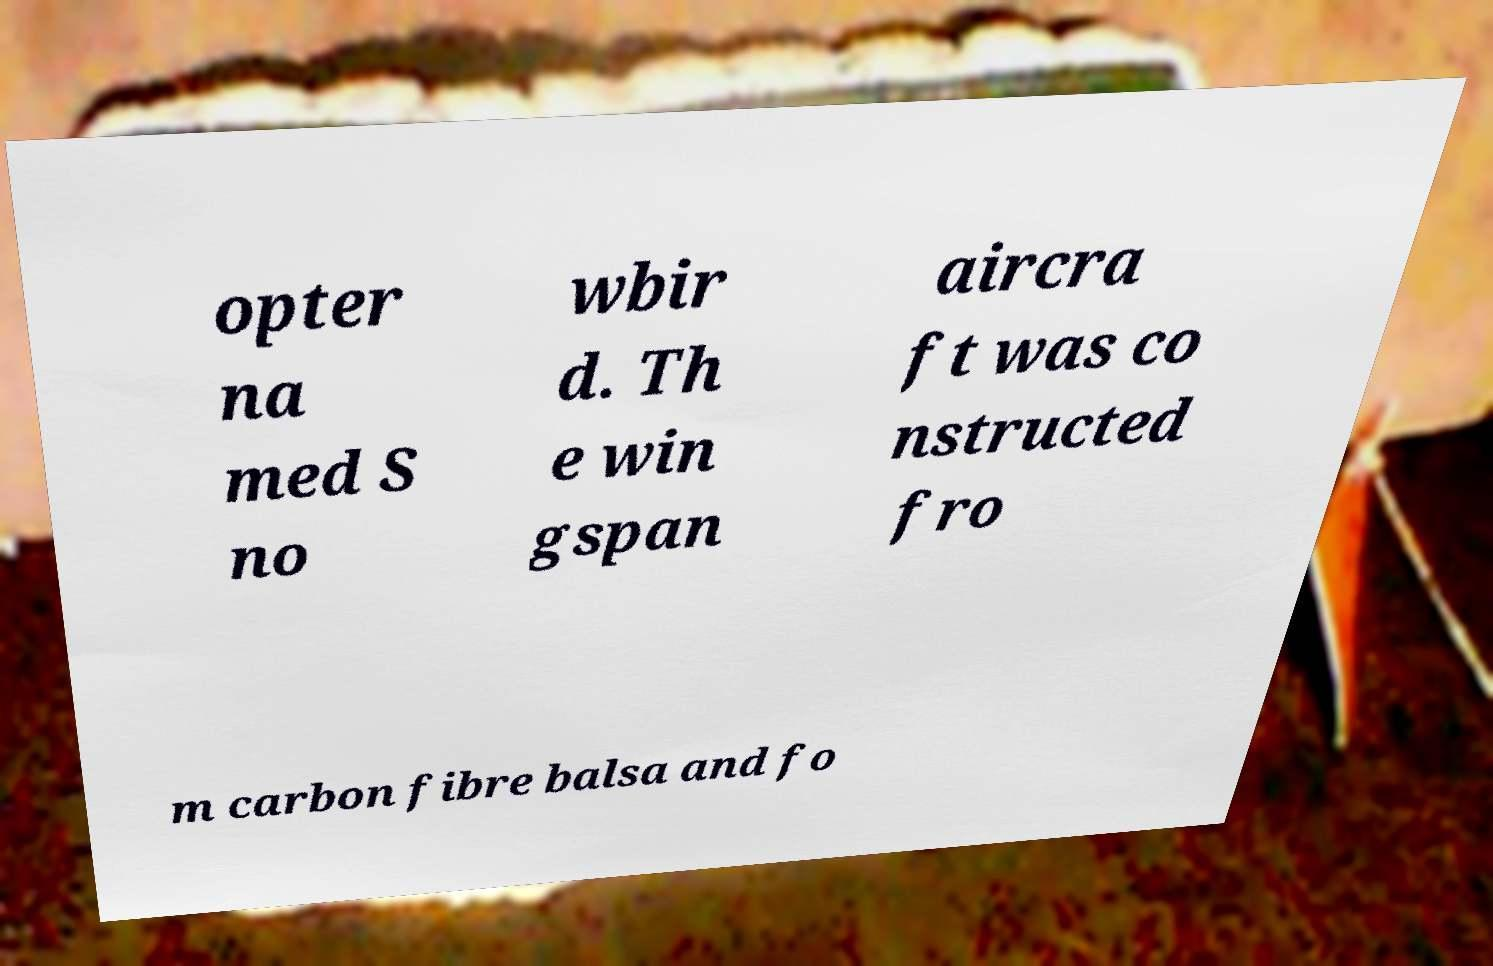I need the written content from this picture converted into text. Can you do that? opter na med S no wbir d. Th e win gspan aircra ft was co nstructed fro m carbon fibre balsa and fo 